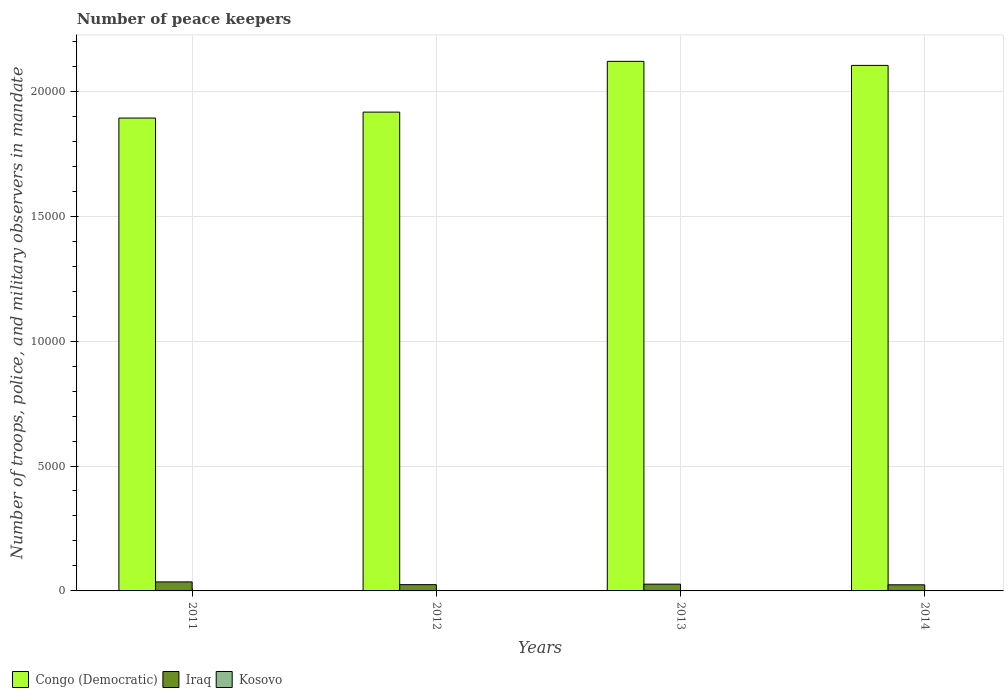How many groups of bars are there?
Your answer should be compact. 4. What is the label of the 1st group of bars from the left?
Give a very brief answer. 2011. What is the number of peace keepers in in Kosovo in 2013?
Your answer should be very brief. 14. Across all years, what is the maximum number of peace keepers in in Iraq?
Give a very brief answer. 361. In which year was the number of peace keepers in in Iraq maximum?
Ensure brevity in your answer.  2011. In which year was the number of peace keepers in in Kosovo minimum?
Provide a succinct answer. 2013. What is the total number of peace keepers in in Kosovo in the graph?
Ensure brevity in your answer.  62. What is the difference between the number of peace keepers in in Kosovo in 2014 and the number of peace keepers in in Congo (Democratic) in 2013?
Offer a terse response. -2.12e+04. In the year 2013, what is the difference between the number of peace keepers in in Iraq and number of peace keepers in in Kosovo?
Make the answer very short. 257. In how many years, is the number of peace keepers in in Congo (Democratic) greater than 4000?
Keep it short and to the point. 4. What is the ratio of the number of peace keepers in in Kosovo in 2012 to that in 2014?
Make the answer very short. 1. What is the difference between the highest and the second highest number of peace keepers in in Iraq?
Offer a very short reply. 90. Is the sum of the number of peace keepers in in Kosovo in 2011 and 2012 greater than the maximum number of peace keepers in in Iraq across all years?
Offer a very short reply. No. What does the 3rd bar from the left in 2013 represents?
Keep it short and to the point. Kosovo. What does the 2nd bar from the right in 2013 represents?
Provide a succinct answer. Iraq. How many bars are there?
Provide a short and direct response. 12. Are all the bars in the graph horizontal?
Your answer should be very brief. No. Are the values on the major ticks of Y-axis written in scientific E-notation?
Your answer should be very brief. No. Does the graph contain grids?
Make the answer very short. Yes. What is the title of the graph?
Keep it short and to the point. Number of peace keepers. What is the label or title of the Y-axis?
Give a very brief answer. Number of troops, police, and military observers in mandate. What is the Number of troops, police, and military observers in mandate in Congo (Democratic) in 2011?
Make the answer very short. 1.89e+04. What is the Number of troops, police, and military observers in mandate of Iraq in 2011?
Offer a terse response. 361. What is the Number of troops, police, and military observers in mandate of Congo (Democratic) in 2012?
Your response must be concise. 1.92e+04. What is the Number of troops, police, and military observers in mandate of Iraq in 2012?
Offer a terse response. 251. What is the Number of troops, police, and military observers in mandate of Kosovo in 2012?
Keep it short and to the point. 16. What is the Number of troops, police, and military observers in mandate of Congo (Democratic) in 2013?
Offer a terse response. 2.12e+04. What is the Number of troops, police, and military observers in mandate of Iraq in 2013?
Provide a short and direct response. 271. What is the Number of troops, police, and military observers in mandate in Kosovo in 2013?
Keep it short and to the point. 14. What is the Number of troops, police, and military observers in mandate in Congo (Democratic) in 2014?
Keep it short and to the point. 2.10e+04. What is the Number of troops, police, and military observers in mandate of Iraq in 2014?
Ensure brevity in your answer.  245. Across all years, what is the maximum Number of troops, police, and military observers in mandate in Congo (Democratic)?
Provide a short and direct response. 2.12e+04. Across all years, what is the maximum Number of troops, police, and military observers in mandate in Iraq?
Offer a terse response. 361. Across all years, what is the maximum Number of troops, police, and military observers in mandate in Kosovo?
Give a very brief answer. 16. Across all years, what is the minimum Number of troops, police, and military observers in mandate of Congo (Democratic)?
Make the answer very short. 1.89e+04. Across all years, what is the minimum Number of troops, police, and military observers in mandate of Iraq?
Make the answer very short. 245. Across all years, what is the minimum Number of troops, police, and military observers in mandate of Kosovo?
Your answer should be very brief. 14. What is the total Number of troops, police, and military observers in mandate in Congo (Democratic) in the graph?
Make the answer very short. 8.03e+04. What is the total Number of troops, police, and military observers in mandate of Iraq in the graph?
Offer a terse response. 1128. What is the difference between the Number of troops, police, and military observers in mandate in Congo (Democratic) in 2011 and that in 2012?
Ensure brevity in your answer.  -238. What is the difference between the Number of troops, police, and military observers in mandate of Iraq in 2011 and that in 2012?
Ensure brevity in your answer.  110. What is the difference between the Number of troops, police, and military observers in mandate in Congo (Democratic) in 2011 and that in 2013?
Give a very brief answer. -2270. What is the difference between the Number of troops, police, and military observers in mandate in Iraq in 2011 and that in 2013?
Offer a terse response. 90. What is the difference between the Number of troops, police, and military observers in mandate of Kosovo in 2011 and that in 2013?
Offer a terse response. 2. What is the difference between the Number of troops, police, and military observers in mandate of Congo (Democratic) in 2011 and that in 2014?
Offer a terse response. -2108. What is the difference between the Number of troops, police, and military observers in mandate of Iraq in 2011 and that in 2014?
Your answer should be compact. 116. What is the difference between the Number of troops, police, and military observers in mandate of Kosovo in 2011 and that in 2014?
Your response must be concise. 0. What is the difference between the Number of troops, police, and military observers in mandate in Congo (Democratic) in 2012 and that in 2013?
Your answer should be very brief. -2032. What is the difference between the Number of troops, police, and military observers in mandate in Iraq in 2012 and that in 2013?
Offer a very short reply. -20. What is the difference between the Number of troops, police, and military observers in mandate in Kosovo in 2012 and that in 2013?
Give a very brief answer. 2. What is the difference between the Number of troops, police, and military observers in mandate of Congo (Democratic) in 2012 and that in 2014?
Provide a succinct answer. -1870. What is the difference between the Number of troops, police, and military observers in mandate of Congo (Democratic) in 2013 and that in 2014?
Provide a short and direct response. 162. What is the difference between the Number of troops, police, and military observers in mandate of Congo (Democratic) in 2011 and the Number of troops, police, and military observers in mandate of Iraq in 2012?
Offer a very short reply. 1.87e+04. What is the difference between the Number of troops, police, and military observers in mandate in Congo (Democratic) in 2011 and the Number of troops, police, and military observers in mandate in Kosovo in 2012?
Your response must be concise. 1.89e+04. What is the difference between the Number of troops, police, and military observers in mandate of Iraq in 2011 and the Number of troops, police, and military observers in mandate of Kosovo in 2012?
Keep it short and to the point. 345. What is the difference between the Number of troops, police, and military observers in mandate of Congo (Democratic) in 2011 and the Number of troops, police, and military observers in mandate of Iraq in 2013?
Your answer should be compact. 1.87e+04. What is the difference between the Number of troops, police, and military observers in mandate of Congo (Democratic) in 2011 and the Number of troops, police, and military observers in mandate of Kosovo in 2013?
Make the answer very short. 1.89e+04. What is the difference between the Number of troops, police, and military observers in mandate in Iraq in 2011 and the Number of troops, police, and military observers in mandate in Kosovo in 2013?
Offer a terse response. 347. What is the difference between the Number of troops, police, and military observers in mandate of Congo (Democratic) in 2011 and the Number of troops, police, and military observers in mandate of Iraq in 2014?
Offer a very short reply. 1.87e+04. What is the difference between the Number of troops, police, and military observers in mandate of Congo (Democratic) in 2011 and the Number of troops, police, and military observers in mandate of Kosovo in 2014?
Provide a succinct answer. 1.89e+04. What is the difference between the Number of troops, police, and military observers in mandate of Iraq in 2011 and the Number of troops, police, and military observers in mandate of Kosovo in 2014?
Offer a very short reply. 345. What is the difference between the Number of troops, police, and military observers in mandate of Congo (Democratic) in 2012 and the Number of troops, police, and military observers in mandate of Iraq in 2013?
Give a very brief answer. 1.89e+04. What is the difference between the Number of troops, police, and military observers in mandate of Congo (Democratic) in 2012 and the Number of troops, police, and military observers in mandate of Kosovo in 2013?
Offer a terse response. 1.92e+04. What is the difference between the Number of troops, police, and military observers in mandate of Iraq in 2012 and the Number of troops, police, and military observers in mandate of Kosovo in 2013?
Your answer should be very brief. 237. What is the difference between the Number of troops, police, and military observers in mandate of Congo (Democratic) in 2012 and the Number of troops, police, and military observers in mandate of Iraq in 2014?
Give a very brief answer. 1.89e+04. What is the difference between the Number of troops, police, and military observers in mandate in Congo (Democratic) in 2012 and the Number of troops, police, and military observers in mandate in Kosovo in 2014?
Your response must be concise. 1.92e+04. What is the difference between the Number of troops, police, and military observers in mandate of Iraq in 2012 and the Number of troops, police, and military observers in mandate of Kosovo in 2014?
Give a very brief answer. 235. What is the difference between the Number of troops, police, and military observers in mandate in Congo (Democratic) in 2013 and the Number of troops, police, and military observers in mandate in Iraq in 2014?
Make the answer very short. 2.10e+04. What is the difference between the Number of troops, police, and military observers in mandate of Congo (Democratic) in 2013 and the Number of troops, police, and military observers in mandate of Kosovo in 2014?
Ensure brevity in your answer.  2.12e+04. What is the difference between the Number of troops, police, and military observers in mandate of Iraq in 2013 and the Number of troops, police, and military observers in mandate of Kosovo in 2014?
Give a very brief answer. 255. What is the average Number of troops, police, and military observers in mandate of Congo (Democratic) per year?
Offer a very short reply. 2.01e+04. What is the average Number of troops, police, and military observers in mandate of Iraq per year?
Make the answer very short. 282. In the year 2011, what is the difference between the Number of troops, police, and military observers in mandate in Congo (Democratic) and Number of troops, police, and military observers in mandate in Iraq?
Make the answer very short. 1.86e+04. In the year 2011, what is the difference between the Number of troops, police, and military observers in mandate in Congo (Democratic) and Number of troops, police, and military observers in mandate in Kosovo?
Your answer should be compact. 1.89e+04. In the year 2011, what is the difference between the Number of troops, police, and military observers in mandate of Iraq and Number of troops, police, and military observers in mandate of Kosovo?
Provide a succinct answer. 345. In the year 2012, what is the difference between the Number of troops, police, and military observers in mandate of Congo (Democratic) and Number of troops, police, and military observers in mandate of Iraq?
Your response must be concise. 1.89e+04. In the year 2012, what is the difference between the Number of troops, police, and military observers in mandate of Congo (Democratic) and Number of troops, police, and military observers in mandate of Kosovo?
Offer a terse response. 1.92e+04. In the year 2012, what is the difference between the Number of troops, police, and military observers in mandate in Iraq and Number of troops, police, and military observers in mandate in Kosovo?
Your answer should be compact. 235. In the year 2013, what is the difference between the Number of troops, police, and military observers in mandate of Congo (Democratic) and Number of troops, police, and military observers in mandate of Iraq?
Make the answer very short. 2.09e+04. In the year 2013, what is the difference between the Number of troops, police, and military observers in mandate of Congo (Democratic) and Number of troops, police, and military observers in mandate of Kosovo?
Keep it short and to the point. 2.12e+04. In the year 2013, what is the difference between the Number of troops, police, and military observers in mandate in Iraq and Number of troops, police, and military observers in mandate in Kosovo?
Offer a terse response. 257. In the year 2014, what is the difference between the Number of troops, police, and military observers in mandate in Congo (Democratic) and Number of troops, police, and military observers in mandate in Iraq?
Your response must be concise. 2.08e+04. In the year 2014, what is the difference between the Number of troops, police, and military observers in mandate in Congo (Democratic) and Number of troops, police, and military observers in mandate in Kosovo?
Keep it short and to the point. 2.10e+04. In the year 2014, what is the difference between the Number of troops, police, and military observers in mandate of Iraq and Number of troops, police, and military observers in mandate of Kosovo?
Your answer should be very brief. 229. What is the ratio of the Number of troops, police, and military observers in mandate in Congo (Democratic) in 2011 to that in 2012?
Ensure brevity in your answer.  0.99. What is the ratio of the Number of troops, police, and military observers in mandate of Iraq in 2011 to that in 2012?
Ensure brevity in your answer.  1.44. What is the ratio of the Number of troops, police, and military observers in mandate of Congo (Democratic) in 2011 to that in 2013?
Your answer should be compact. 0.89. What is the ratio of the Number of troops, police, and military observers in mandate of Iraq in 2011 to that in 2013?
Give a very brief answer. 1.33. What is the ratio of the Number of troops, police, and military observers in mandate of Kosovo in 2011 to that in 2013?
Offer a terse response. 1.14. What is the ratio of the Number of troops, police, and military observers in mandate in Congo (Democratic) in 2011 to that in 2014?
Ensure brevity in your answer.  0.9. What is the ratio of the Number of troops, police, and military observers in mandate in Iraq in 2011 to that in 2014?
Your response must be concise. 1.47. What is the ratio of the Number of troops, police, and military observers in mandate in Congo (Democratic) in 2012 to that in 2013?
Make the answer very short. 0.9. What is the ratio of the Number of troops, police, and military observers in mandate in Iraq in 2012 to that in 2013?
Provide a short and direct response. 0.93. What is the ratio of the Number of troops, police, and military observers in mandate of Kosovo in 2012 to that in 2013?
Provide a succinct answer. 1.14. What is the ratio of the Number of troops, police, and military observers in mandate in Congo (Democratic) in 2012 to that in 2014?
Your answer should be compact. 0.91. What is the ratio of the Number of troops, police, and military observers in mandate of Iraq in 2012 to that in 2014?
Your answer should be compact. 1.02. What is the ratio of the Number of troops, police, and military observers in mandate of Kosovo in 2012 to that in 2014?
Keep it short and to the point. 1. What is the ratio of the Number of troops, police, and military observers in mandate in Congo (Democratic) in 2013 to that in 2014?
Keep it short and to the point. 1.01. What is the ratio of the Number of troops, police, and military observers in mandate of Iraq in 2013 to that in 2014?
Provide a succinct answer. 1.11. What is the difference between the highest and the second highest Number of troops, police, and military observers in mandate of Congo (Democratic)?
Offer a very short reply. 162. What is the difference between the highest and the second highest Number of troops, police, and military observers in mandate of Iraq?
Your response must be concise. 90. What is the difference between the highest and the second highest Number of troops, police, and military observers in mandate in Kosovo?
Make the answer very short. 0. What is the difference between the highest and the lowest Number of troops, police, and military observers in mandate of Congo (Democratic)?
Your answer should be compact. 2270. What is the difference between the highest and the lowest Number of troops, police, and military observers in mandate of Iraq?
Give a very brief answer. 116. What is the difference between the highest and the lowest Number of troops, police, and military observers in mandate in Kosovo?
Your answer should be very brief. 2. 